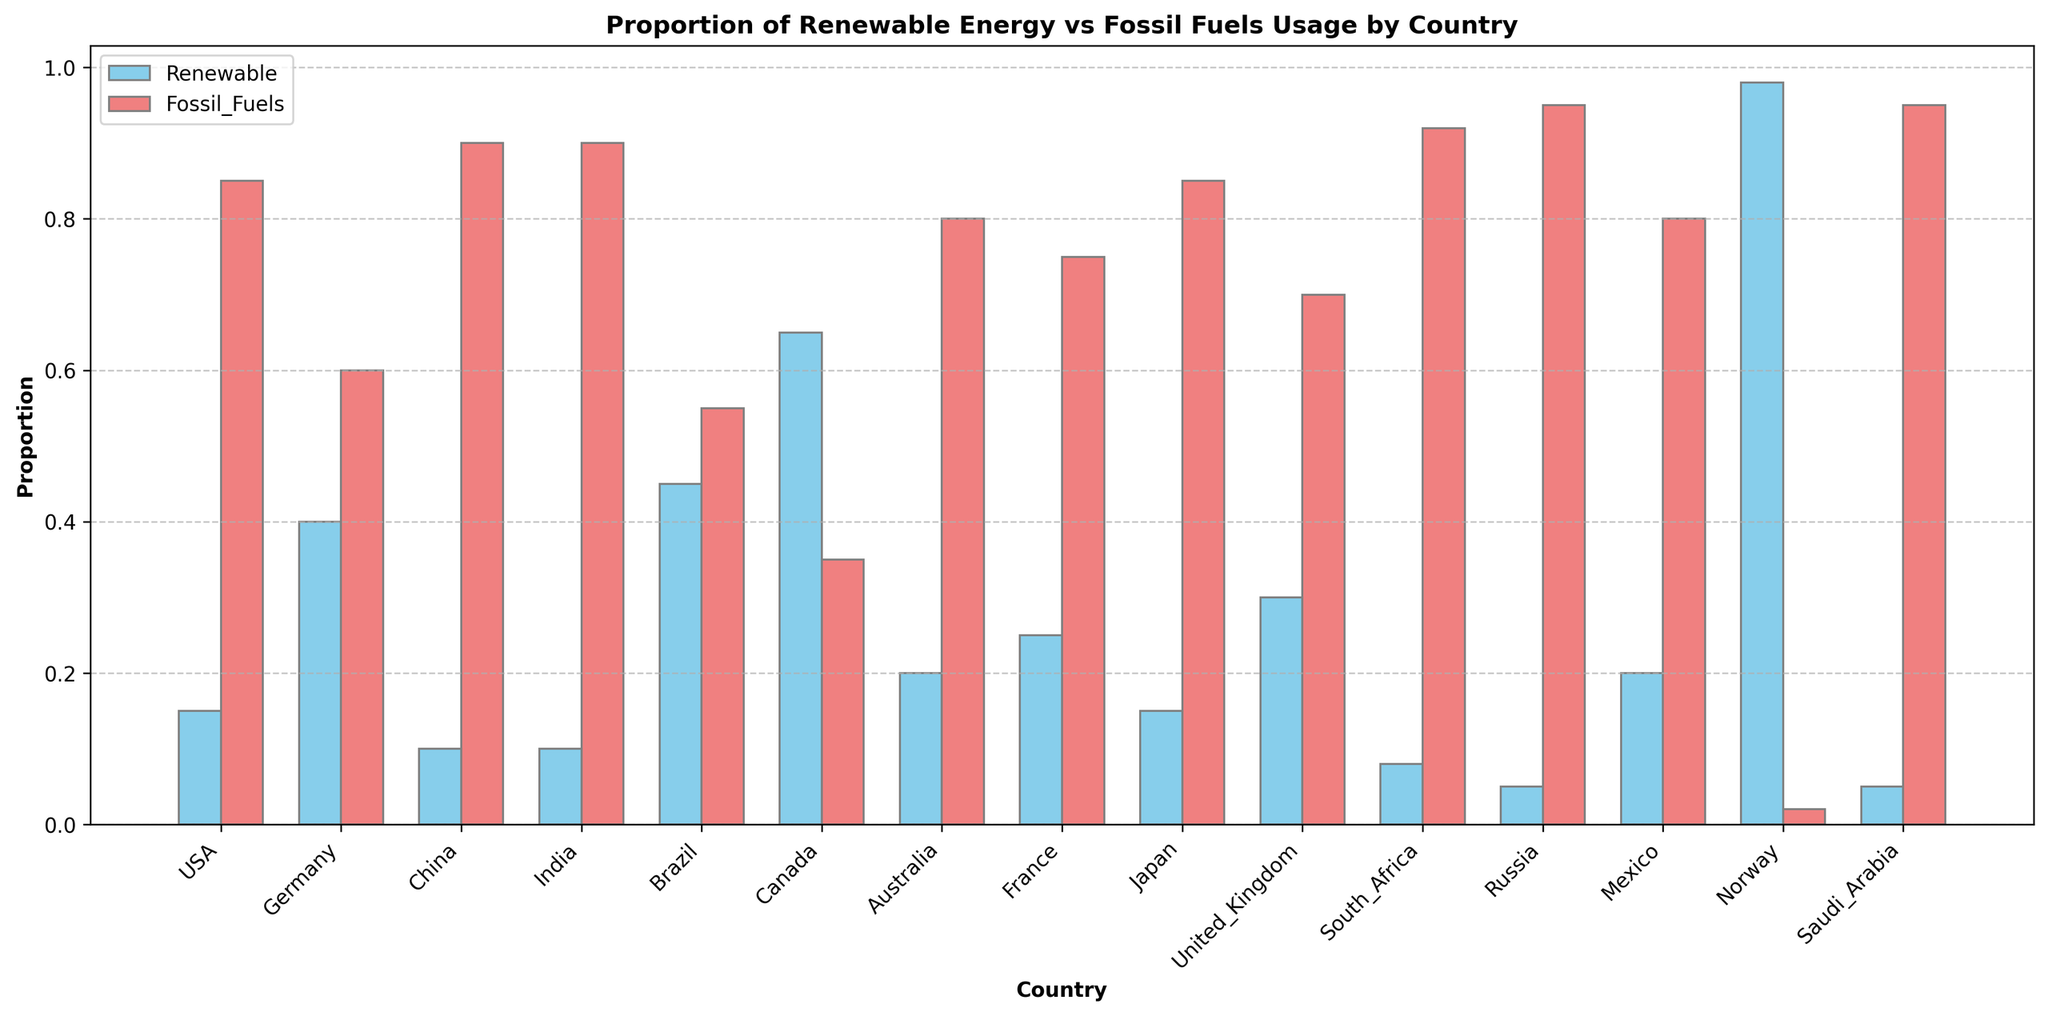Which country has the highest proportion of renewable energy usage? By observing the height of the light blue bars representing renewable energy, Norway clearly has the highest bar, indicating the highest proportion of renewable energy usage.
Answer: Norway Compare the proportion of renewable energy usage between Brazil and India. Brazil has a renewable energy proportion of 0.45, while India has 0.10. This means that Brazil has a significantly higher proportion compared to India.
Answer: Brazil higher Which countries have the same proportion of renewable energy usage? By looking at the heights of the light blue bars, China and India both have the same proportion of renewable energy usage of 0.10 each.
Answer: China and India What is the combined proportion of renewable energy usage for Canada and Germany? Canada has 0.65 and Germany has 0.40 renewable energy proportion. Adding them together: 0.65 + 0.40 = 1.05.
Answer: 1.05 What is the difference in fossil fuel usage between the USA and Japan? The USA has a fossil fuel usage proportion of 0.85, while Japan has the same proportion of 0.85. Subtracting: 0.85 - 0.85 = 0.
Answer: 0 Identify the country with the lowest renewable energy usage and state its proportion. By observing the height of all light blue bars, Russia and Saudi Arabia both have the shortest bars, indicating the lowest renewable energy usage proportion of 0.05 each.
Answer: Russia and Saudi Arabia, 0.05 Which country has a greater proportion of fossil fuel usage, France or the United Kingdom? France has a fossil fuel usage proportion of 0.75, while the United Kingdom has 0.70. Therefore, France has a greater proportion of fossil fuel usage.
Answer: France What is the average proportion of renewable energy usage among Brazil, Norway, and Mexico? Brazil has 0.45, Norway has 0.98, and Mexico has 0.20. Adding them together: 0.45 + 0.98 + 0.20 = 1.63. Dividing by the number of countries (3): 1.63 / 3 ≈ 0.54.
Answer: 0.54 How much more renewable energy does Canada use compared to Australia? Canada has a renewable energy proportion of 0.65, while Australia has 0.20. Subtracting: 0.65 - 0.20 = 0.45.
Answer: 0.45 Which country has the closest renewable energy usage proportion to 0.30? By observing the heights of the light blue bars, the United Kingdom is closest to 0.30 with exactly that value.
Answer: United Kingdom 